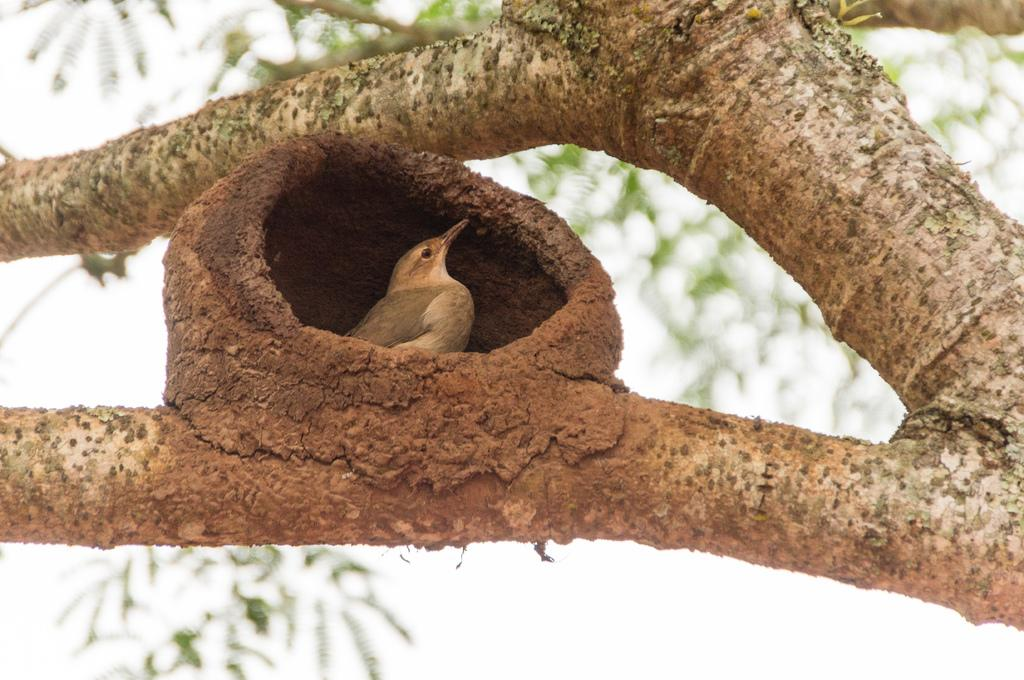What type of natural elements can be seen in the image? There are branches and leaves present in the image. Can you describe the bird's location in the image? The bird is in a nest in the image. What is visible in the background of the image? The sky is visible in the background of the image. What type of tax does the bird pay for living in the nest in the image? There is no mention of taxes in the image, and the bird's living situation does not involve any taxation. 